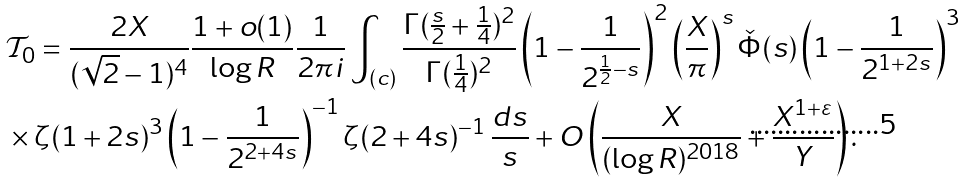<formula> <loc_0><loc_0><loc_500><loc_500>& \mathcal { T } _ { 0 } = \frac { 2 X } { ( \sqrt { 2 } - 1 ) ^ { 4 } } \frac { 1 + o ( 1 ) } { \log R } \frac { 1 } { 2 \pi i } \int _ { ( c ) } \frac { \Gamma ( \frac { s } { 2 } + \frac { 1 } { 4 } ) ^ { 2 } } { \Gamma ( \frac { 1 } { 4 } ) ^ { 2 } } \left ( 1 - \frac { 1 } { 2 ^ { \frac { 1 } { 2 } - s } } \right ) ^ { 2 } \left ( \frac { X } { \pi } \right ) ^ { s } \check { \Phi } ( s ) \left ( 1 - \frac { 1 } { 2 ^ { 1 + 2 s } } \right ) ^ { 3 } \\ & \times \zeta ( 1 + 2 s ) ^ { 3 } \left ( 1 - \frac { 1 } { 2 ^ { 2 + 4 s } } \right ) ^ { - 1 } \zeta ( 2 + 4 s ) ^ { - 1 } \, \frac { d s } { s } + O \left ( \frac { X } { ( \log R ) ^ { 2 0 1 8 } } + \frac { X ^ { 1 + \varepsilon } } { Y } \right ) .</formula> 